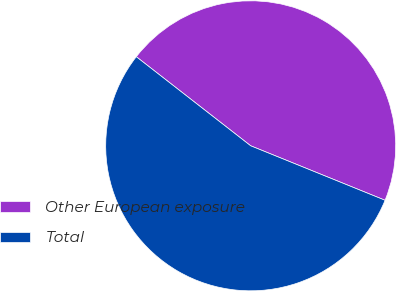Convert chart to OTSL. <chart><loc_0><loc_0><loc_500><loc_500><pie_chart><fcel>Other European exposure<fcel>Total<nl><fcel>45.6%<fcel>54.4%<nl></chart> 